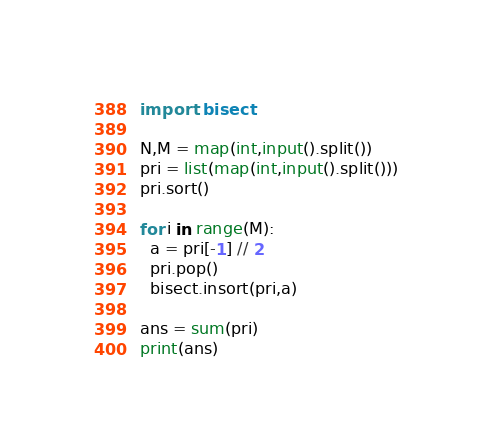<code> <loc_0><loc_0><loc_500><loc_500><_Python_>import  bisect

N,M = map(int,input().split())
pri = list(map(int,input().split()))
pri.sort()

for i in range(M):
  a = pri[-1] // 2
  pri.pop()
  bisect.insort(pri,a)

ans = sum(pri)
print(ans)</code> 